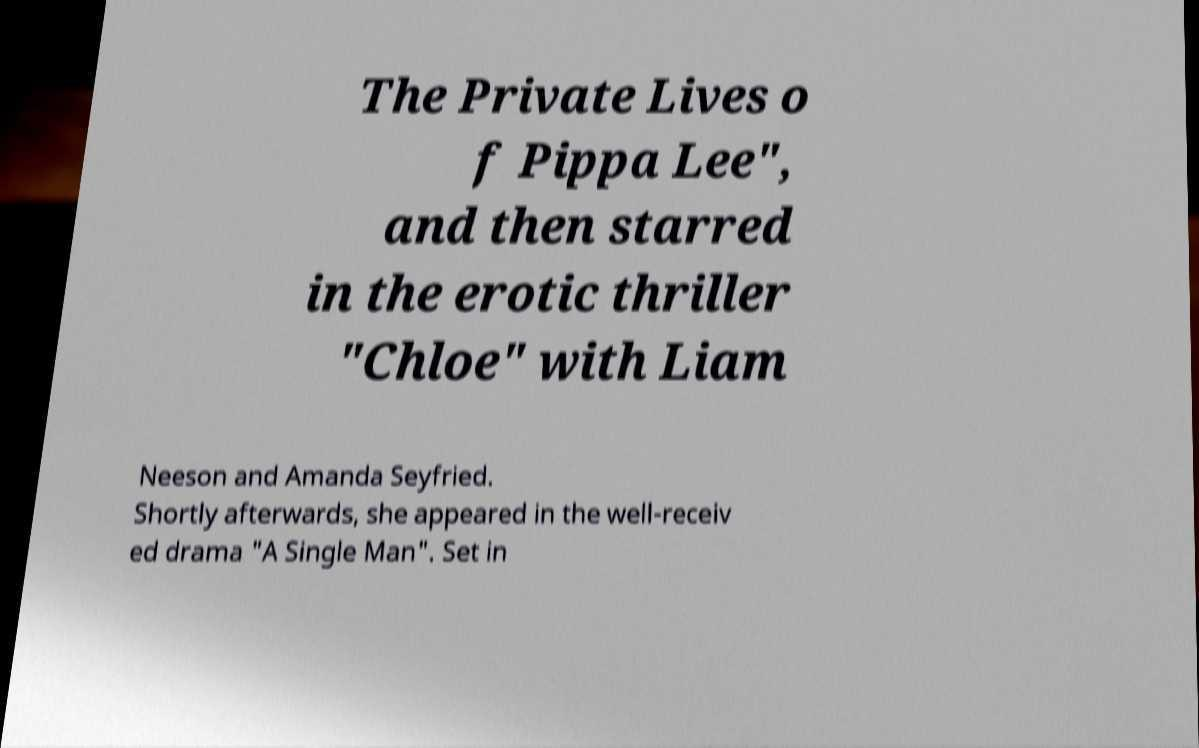Can you accurately transcribe the text from the provided image for me? The Private Lives o f Pippa Lee", and then starred in the erotic thriller "Chloe" with Liam Neeson and Amanda Seyfried. Shortly afterwards, she appeared in the well-receiv ed drama "A Single Man". Set in 